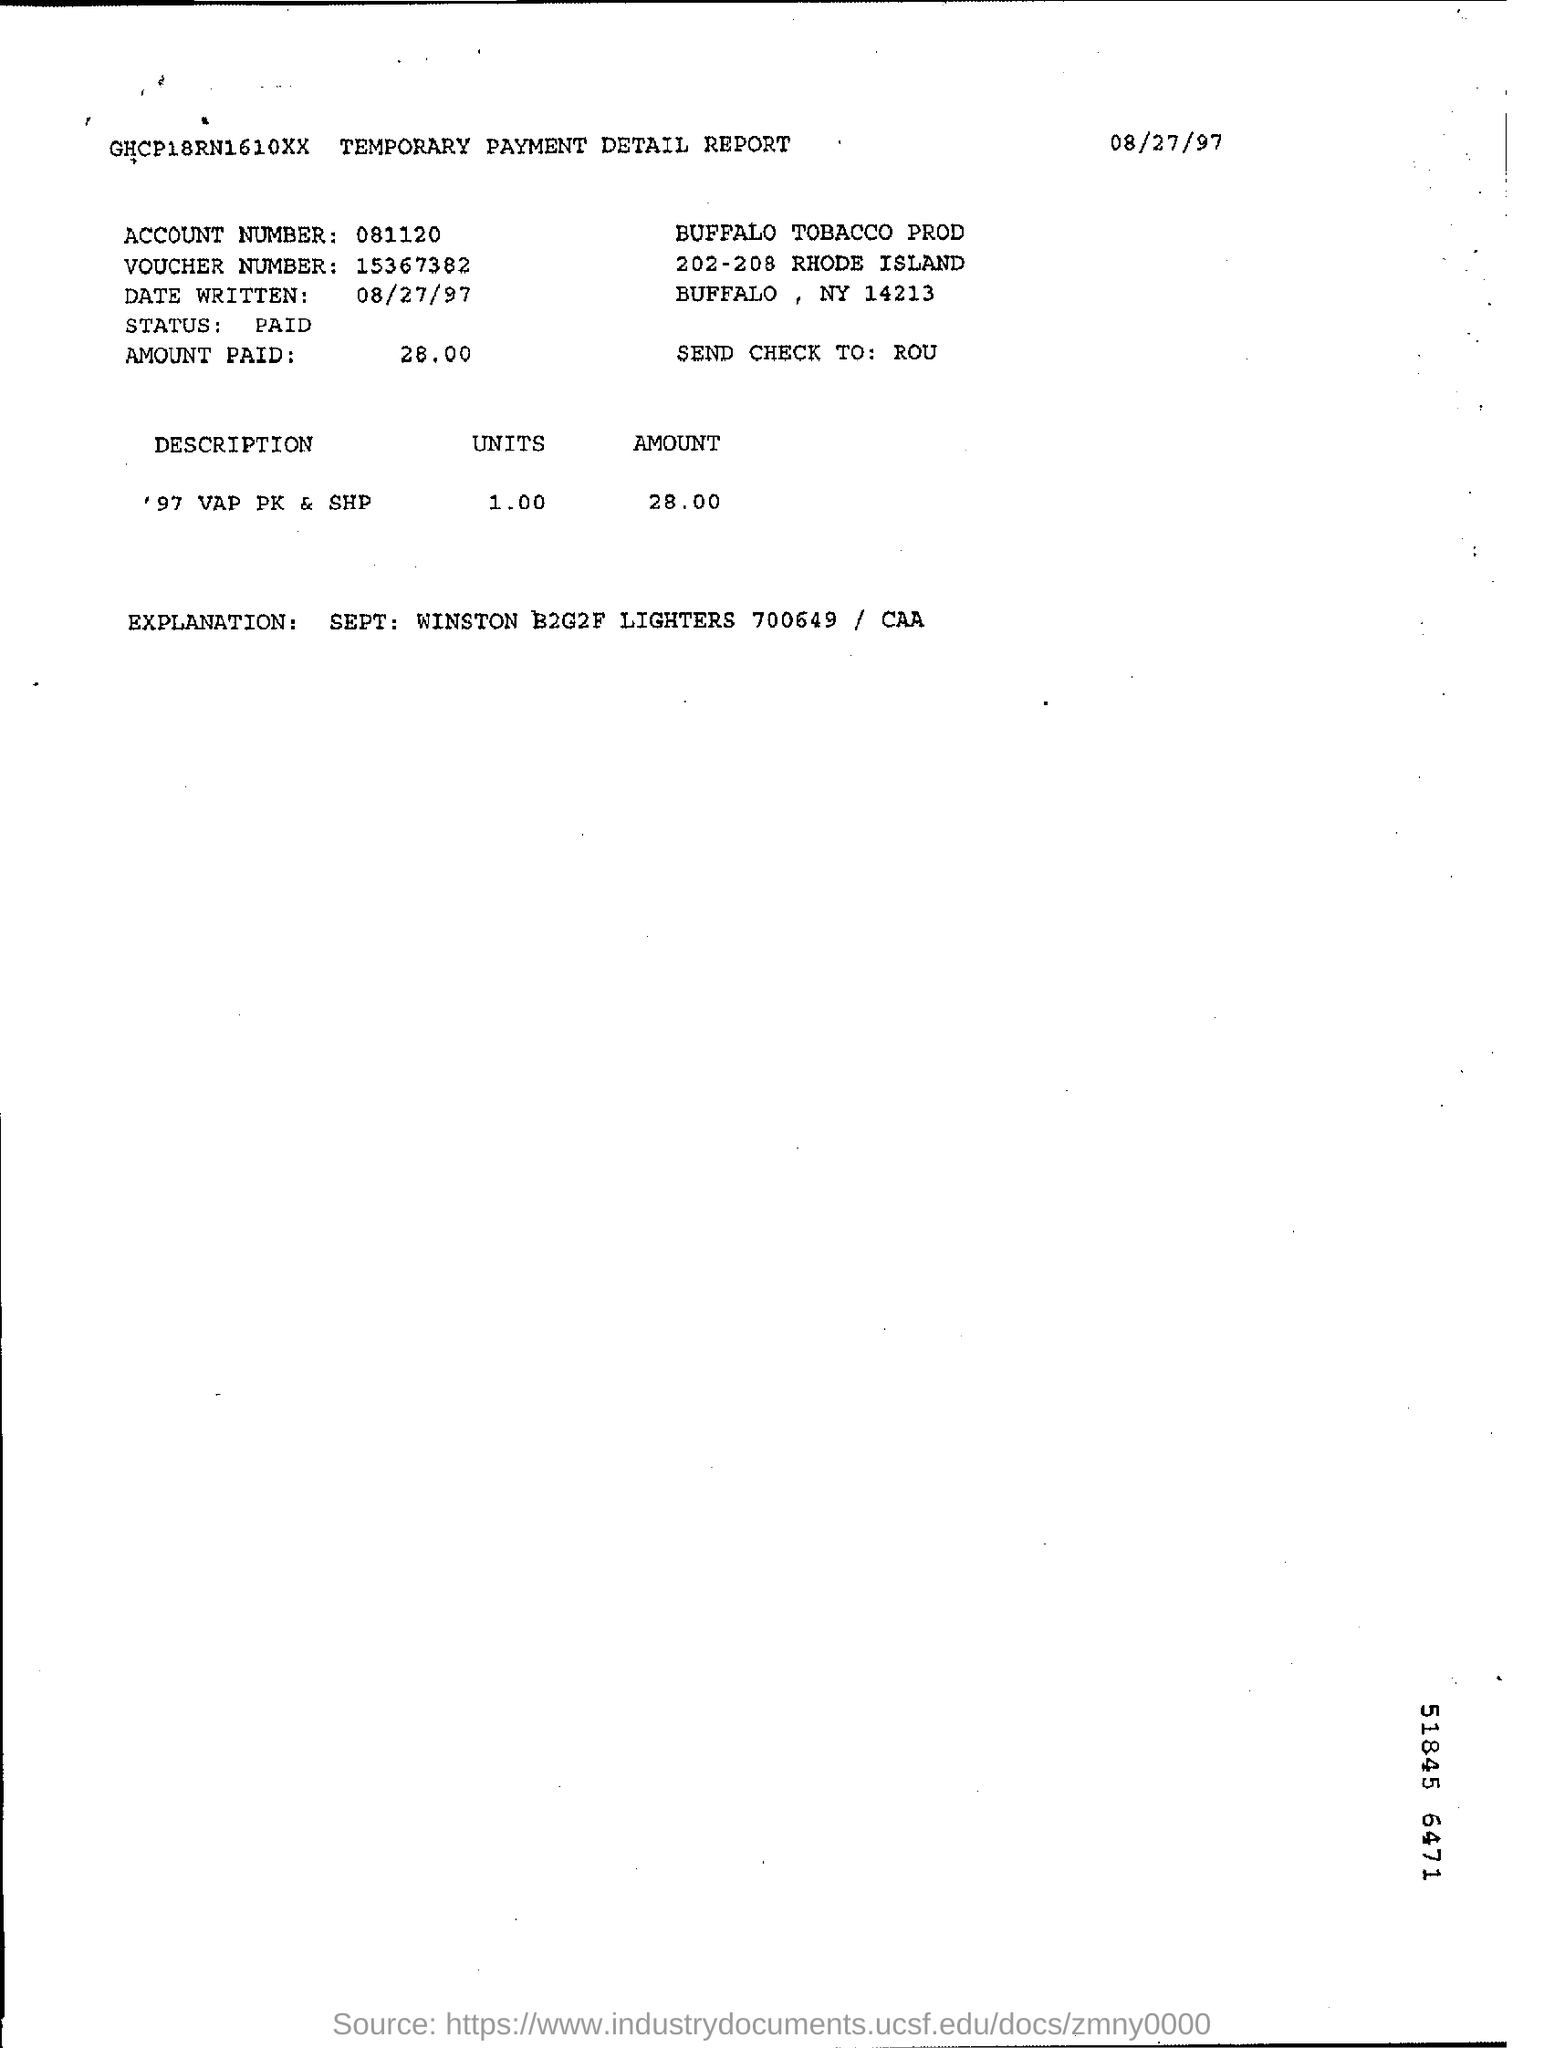What is the status of voucher?
Your answer should be compact. Paid. What is the amount paid?
Provide a short and direct response. 28.00. 